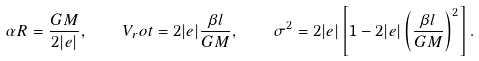<formula> <loc_0><loc_0><loc_500><loc_500>\alpha R = \frac { G M } { 2 | e | } , \quad V _ { r } o t = 2 | e | \frac { \beta l } { G M } , \quad \sigma ^ { 2 } = 2 | e | \left [ 1 - 2 | e | \left ( \frac { \beta l } { G M } \right ) ^ { 2 } \right ] .</formula> 